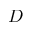<formula> <loc_0><loc_0><loc_500><loc_500>D</formula> 